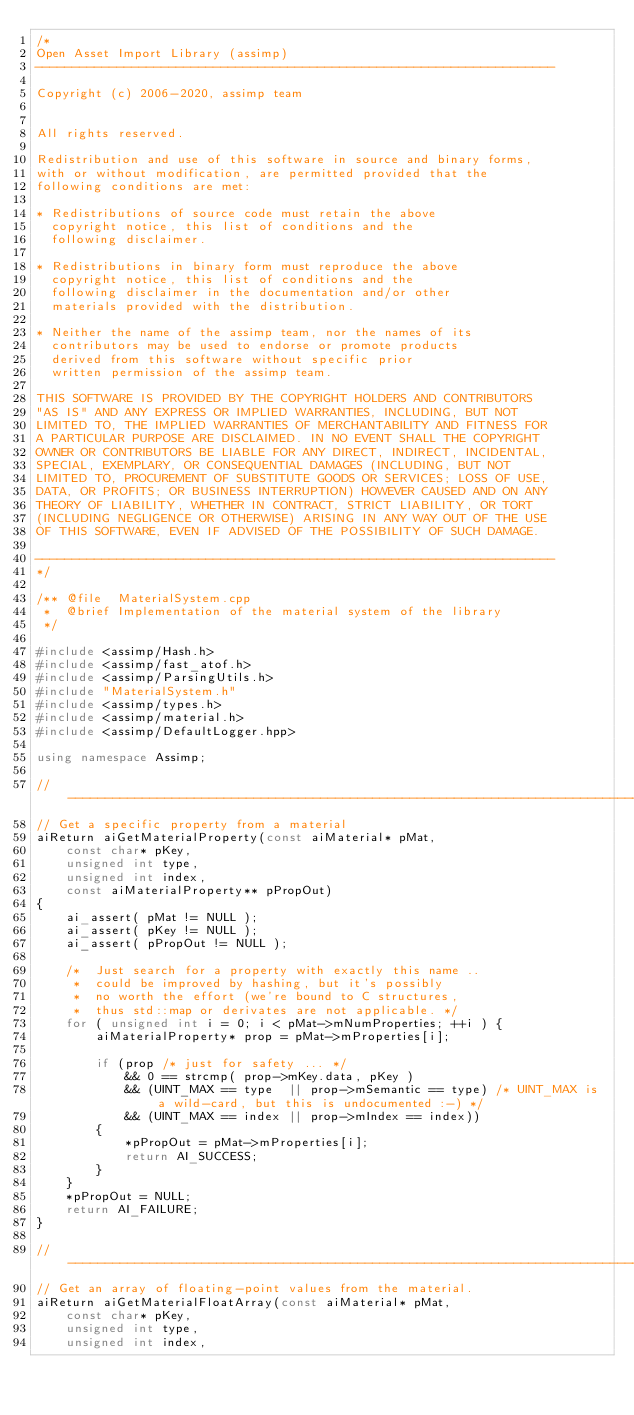<code> <loc_0><loc_0><loc_500><loc_500><_C++_>/*
Open Asset Import Library (assimp)
----------------------------------------------------------------------

Copyright (c) 2006-2020, assimp team


All rights reserved.

Redistribution and use of this software in source and binary forms,
with or without modification, are permitted provided that the
following conditions are met:

* Redistributions of source code must retain the above
  copyright notice, this list of conditions and the
  following disclaimer.

* Redistributions in binary form must reproduce the above
  copyright notice, this list of conditions and the
  following disclaimer in the documentation and/or other
  materials provided with the distribution.

* Neither the name of the assimp team, nor the names of its
  contributors may be used to endorse or promote products
  derived from this software without specific prior
  written permission of the assimp team.

THIS SOFTWARE IS PROVIDED BY THE COPYRIGHT HOLDERS AND CONTRIBUTORS
"AS IS" AND ANY EXPRESS OR IMPLIED WARRANTIES, INCLUDING, BUT NOT
LIMITED TO, THE IMPLIED WARRANTIES OF MERCHANTABILITY AND FITNESS FOR
A PARTICULAR PURPOSE ARE DISCLAIMED. IN NO EVENT SHALL THE COPYRIGHT
OWNER OR CONTRIBUTORS BE LIABLE FOR ANY DIRECT, INDIRECT, INCIDENTAL,
SPECIAL, EXEMPLARY, OR CONSEQUENTIAL DAMAGES (INCLUDING, BUT NOT
LIMITED TO, PROCUREMENT OF SUBSTITUTE GOODS OR SERVICES; LOSS OF USE,
DATA, OR PROFITS; OR BUSINESS INTERRUPTION) HOWEVER CAUSED AND ON ANY
THEORY OF LIABILITY, WHETHER IN CONTRACT, STRICT LIABILITY, OR TORT
(INCLUDING NEGLIGENCE OR OTHERWISE) ARISING IN ANY WAY OUT OF THE USE
OF THIS SOFTWARE, EVEN IF ADVISED OF THE POSSIBILITY OF SUCH DAMAGE.

----------------------------------------------------------------------
*/

/** @file  MaterialSystem.cpp
 *  @brief Implementation of the material system of the library
 */

#include <assimp/Hash.h>
#include <assimp/fast_atof.h>
#include <assimp/ParsingUtils.h>
#include "MaterialSystem.h"
#include <assimp/types.h>
#include <assimp/material.h>
#include <assimp/DefaultLogger.hpp>

using namespace Assimp;

// ------------------------------------------------------------------------------------------------
// Get a specific property from a material
aiReturn aiGetMaterialProperty(const aiMaterial* pMat,
    const char* pKey,
    unsigned int type,
    unsigned int index,
    const aiMaterialProperty** pPropOut)
{
    ai_assert( pMat != NULL );
    ai_assert( pKey != NULL );
    ai_assert( pPropOut != NULL );

    /*  Just search for a property with exactly this name ..
     *  could be improved by hashing, but it's possibly
     *  no worth the effort (we're bound to C structures,
     *  thus std::map or derivates are not applicable. */
    for ( unsigned int i = 0; i < pMat->mNumProperties; ++i ) {
        aiMaterialProperty* prop = pMat->mProperties[i];

        if (prop /* just for safety ... */
            && 0 == strcmp( prop->mKey.data, pKey )
            && (UINT_MAX == type  || prop->mSemantic == type) /* UINT_MAX is a wild-card, but this is undocumented :-) */
            && (UINT_MAX == index || prop->mIndex == index))
        {
            *pPropOut = pMat->mProperties[i];
            return AI_SUCCESS;
        }
    }
    *pPropOut = NULL;
    return AI_FAILURE;
}

// ------------------------------------------------------------------------------------------------
// Get an array of floating-point values from the material.
aiReturn aiGetMaterialFloatArray(const aiMaterial* pMat,
    const char* pKey,
    unsigned int type,
    unsigned int index,</code> 